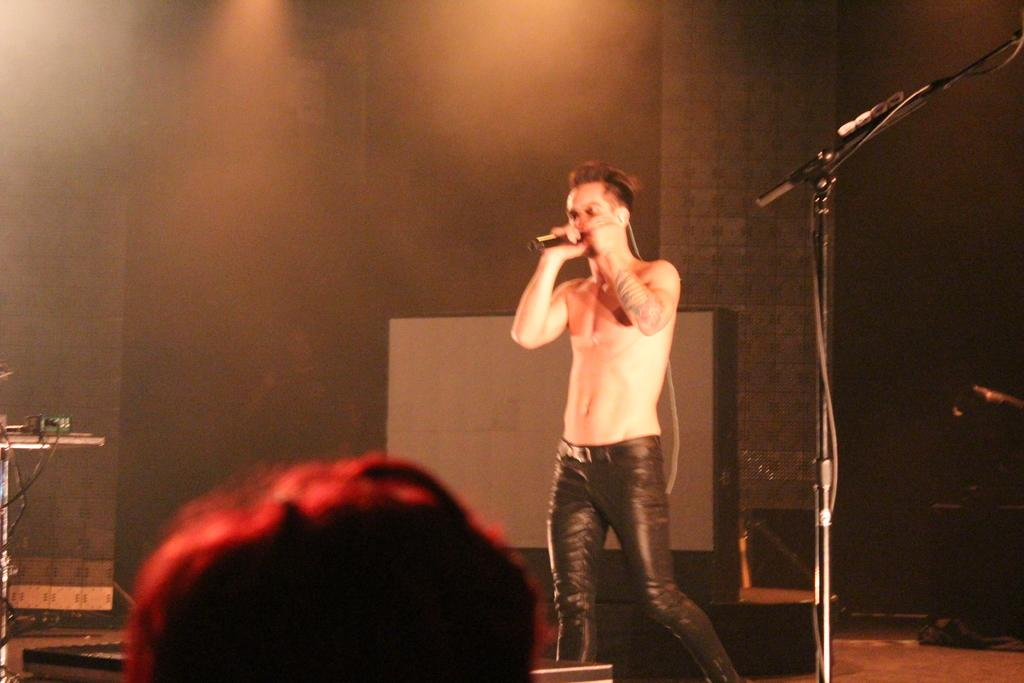What is the man in the image doing? The man is singing on a mic. Can you describe the mic stand in the image? There is a mic stand on the right side of the image. How would you describe the lighting in the image? The background is dark, and there is light focused coming from the ceiling. How does the man use his wrist to control the brake while singing on the mic? There is no brake present in the image, and the man is not shown controlling any vehicle while singing. 